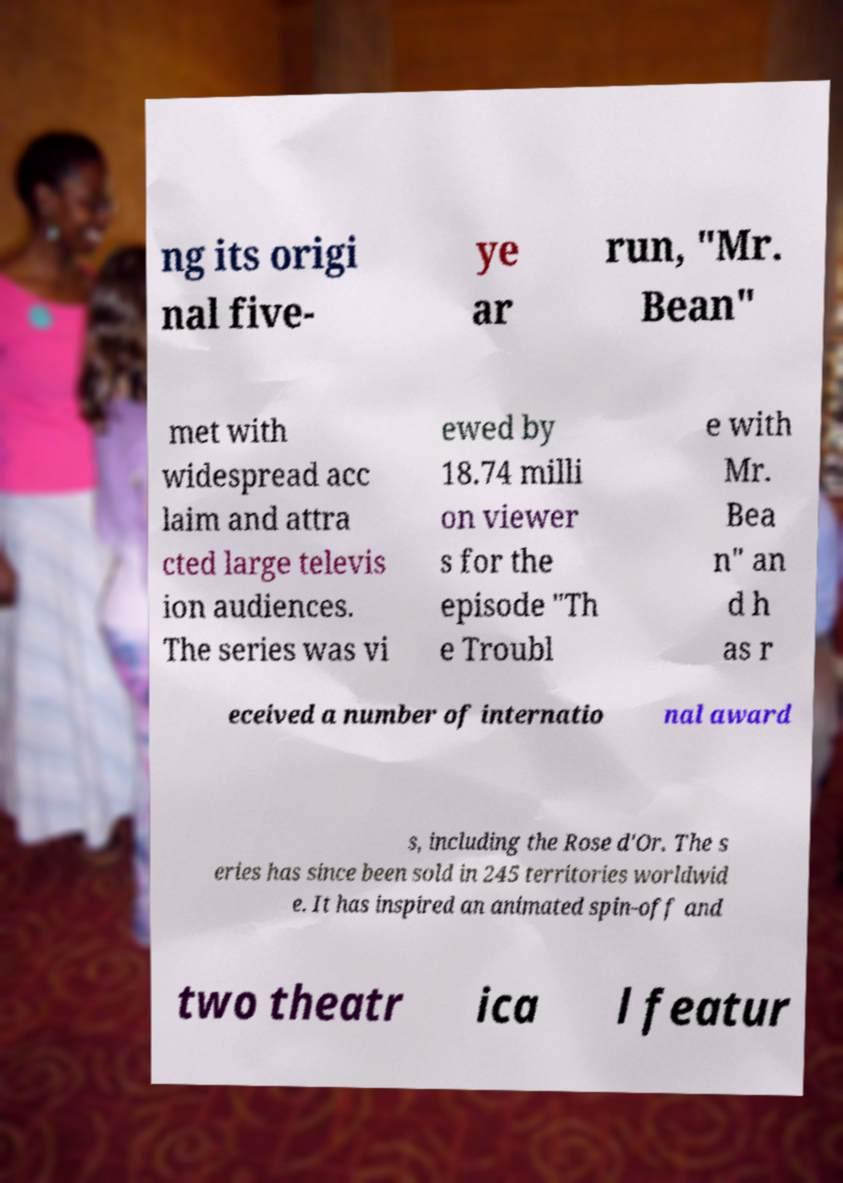For documentation purposes, I need the text within this image transcribed. Could you provide that? ng its origi nal five- ye ar run, "Mr. Bean" met with widespread acc laim and attra cted large televis ion audiences. The series was vi ewed by 18.74 milli on viewer s for the episode "Th e Troubl e with Mr. Bea n" an d h as r eceived a number of internatio nal award s, including the Rose d'Or. The s eries has since been sold in 245 territories worldwid e. It has inspired an animated spin-off and two theatr ica l featur 